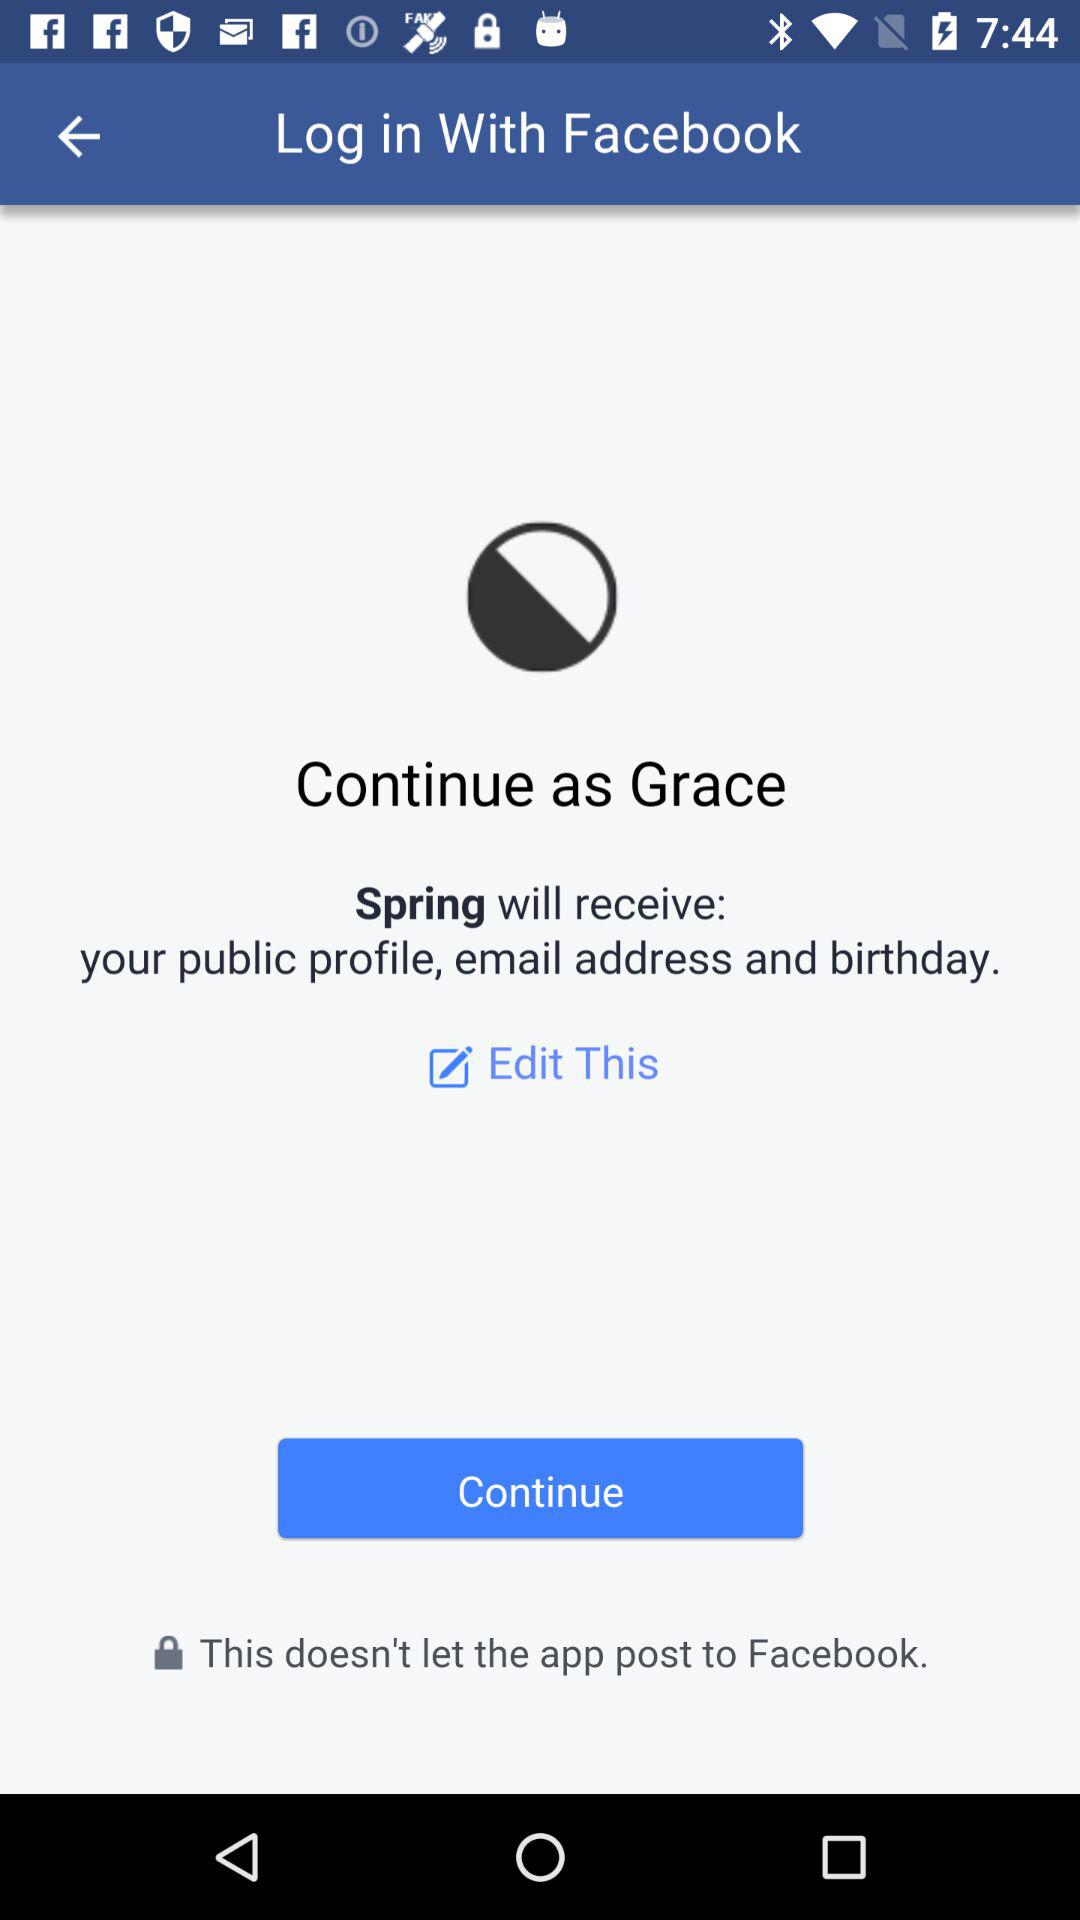What application will receive the public profile, email address and birthday? The application "Spring" will receive the public profile, email address and birthday. 